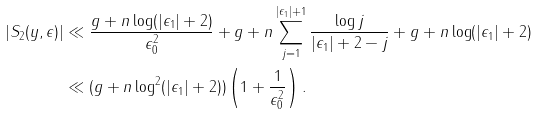<formula> <loc_0><loc_0><loc_500><loc_500>| S _ { 2 } ( y , \epsilon ) | & \ll \frac { g + n \log ( | \epsilon _ { 1 } | + 2 ) } { \epsilon _ { 0 } ^ { 2 } } + g + n \sum _ { j = 1 } ^ { | \epsilon _ { 1 } | + 1 } \frac { \log j } { | \epsilon _ { 1 } | + 2 - j } + g + n \log ( | \epsilon _ { 1 } | + 2 ) \\ & \ll ( g + n \log ^ { 2 } ( | \epsilon _ { 1 } | + 2 ) ) \left ( 1 + \frac { 1 } { \epsilon _ { 0 } ^ { 2 } } \right ) .</formula> 